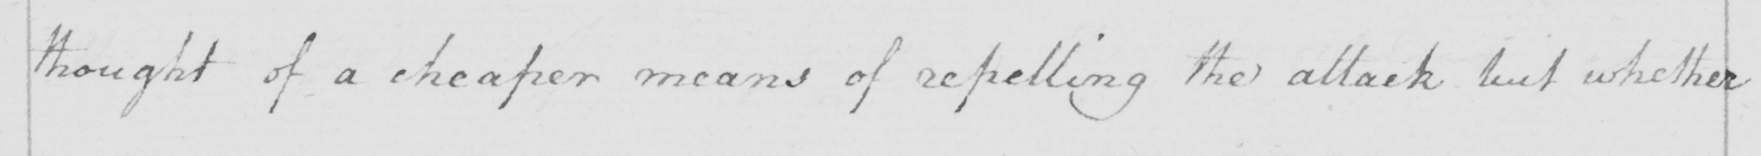Please transcribe the handwritten text in this image. thought of a cheaper means of repelling the attack but whether 